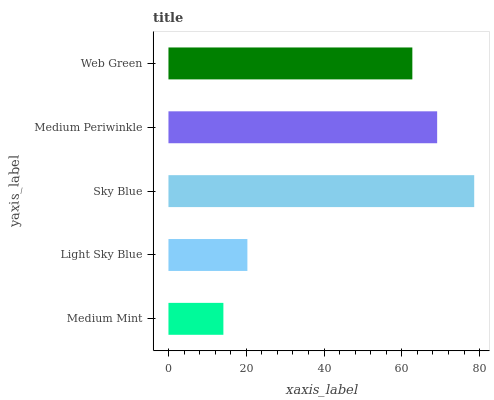Is Medium Mint the minimum?
Answer yes or no. Yes. Is Sky Blue the maximum?
Answer yes or no. Yes. Is Light Sky Blue the minimum?
Answer yes or no. No. Is Light Sky Blue the maximum?
Answer yes or no. No. Is Light Sky Blue greater than Medium Mint?
Answer yes or no. Yes. Is Medium Mint less than Light Sky Blue?
Answer yes or no. Yes. Is Medium Mint greater than Light Sky Blue?
Answer yes or no. No. Is Light Sky Blue less than Medium Mint?
Answer yes or no. No. Is Web Green the high median?
Answer yes or no. Yes. Is Web Green the low median?
Answer yes or no. Yes. Is Light Sky Blue the high median?
Answer yes or no. No. Is Medium Mint the low median?
Answer yes or no. No. 